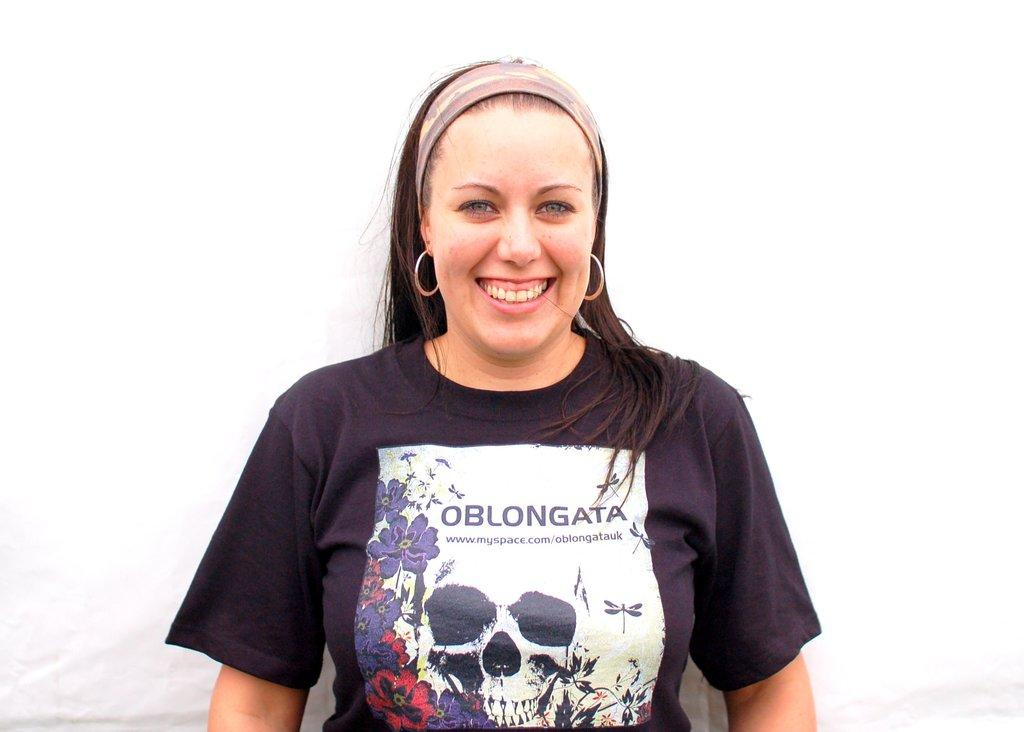What is the main subject of the image? There is a woman in the image. What is the woman doing in the image? The woman is standing and smiling. What is the woman wearing in the image? The woman is wearing a t-shirt. What is the color of the background in the image? The background of the image is white in color. Can you tell me how many judges are present in the image? There are no judges present in the image; it features a woman standing and smiling. What type of cemetery can be seen in the background of the image? There is no cemetery present in the image; the background is white in color. 